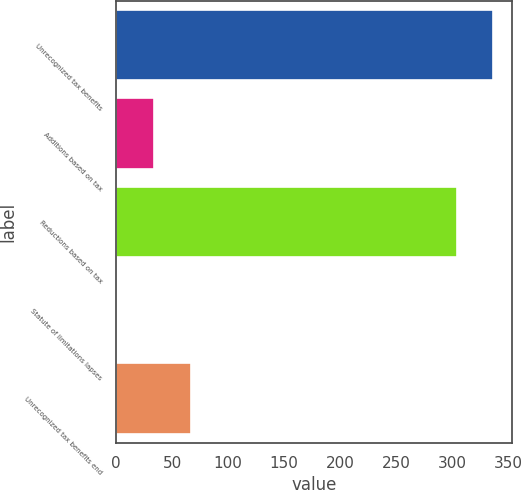<chart> <loc_0><loc_0><loc_500><loc_500><bar_chart><fcel>Unrecognized tax benefits<fcel>Additions based on tax<fcel>Reductions based on tax<fcel>Statute of limitations lapses<fcel>Unrecognized tax benefits end<nl><fcel>336.9<fcel>33.9<fcel>304<fcel>1<fcel>66.8<nl></chart> 